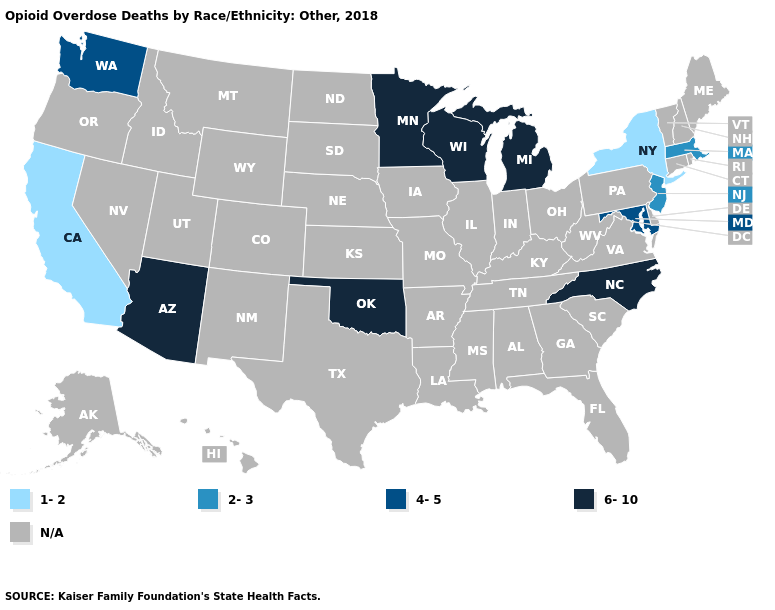Name the states that have a value in the range 6-10?
Concise answer only. Arizona, Michigan, Minnesota, North Carolina, Oklahoma, Wisconsin. What is the value of South Dakota?
Quick response, please. N/A. What is the highest value in states that border New Jersey?
Be succinct. 1-2. How many symbols are there in the legend?
Write a very short answer. 5. Name the states that have a value in the range 2-3?
Short answer required. Massachusetts, New Jersey. How many symbols are there in the legend?
Be succinct. 5. Name the states that have a value in the range 6-10?
Be succinct. Arizona, Michigan, Minnesota, North Carolina, Oklahoma, Wisconsin. What is the value of California?
Be succinct. 1-2. Name the states that have a value in the range 6-10?
Give a very brief answer. Arizona, Michigan, Minnesota, North Carolina, Oklahoma, Wisconsin. Which states have the highest value in the USA?
Quick response, please. Arizona, Michigan, Minnesota, North Carolina, Oklahoma, Wisconsin. Is the legend a continuous bar?
Short answer required. No. What is the value of Maryland?
Be succinct. 4-5. Does the map have missing data?
Concise answer only. Yes. 